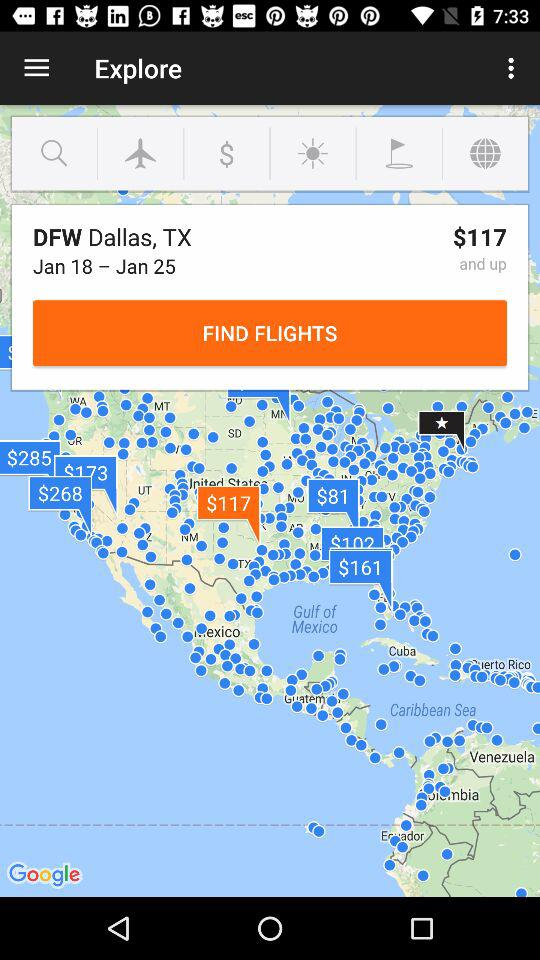What is the date range? The date range is from January 18 to January 25. 